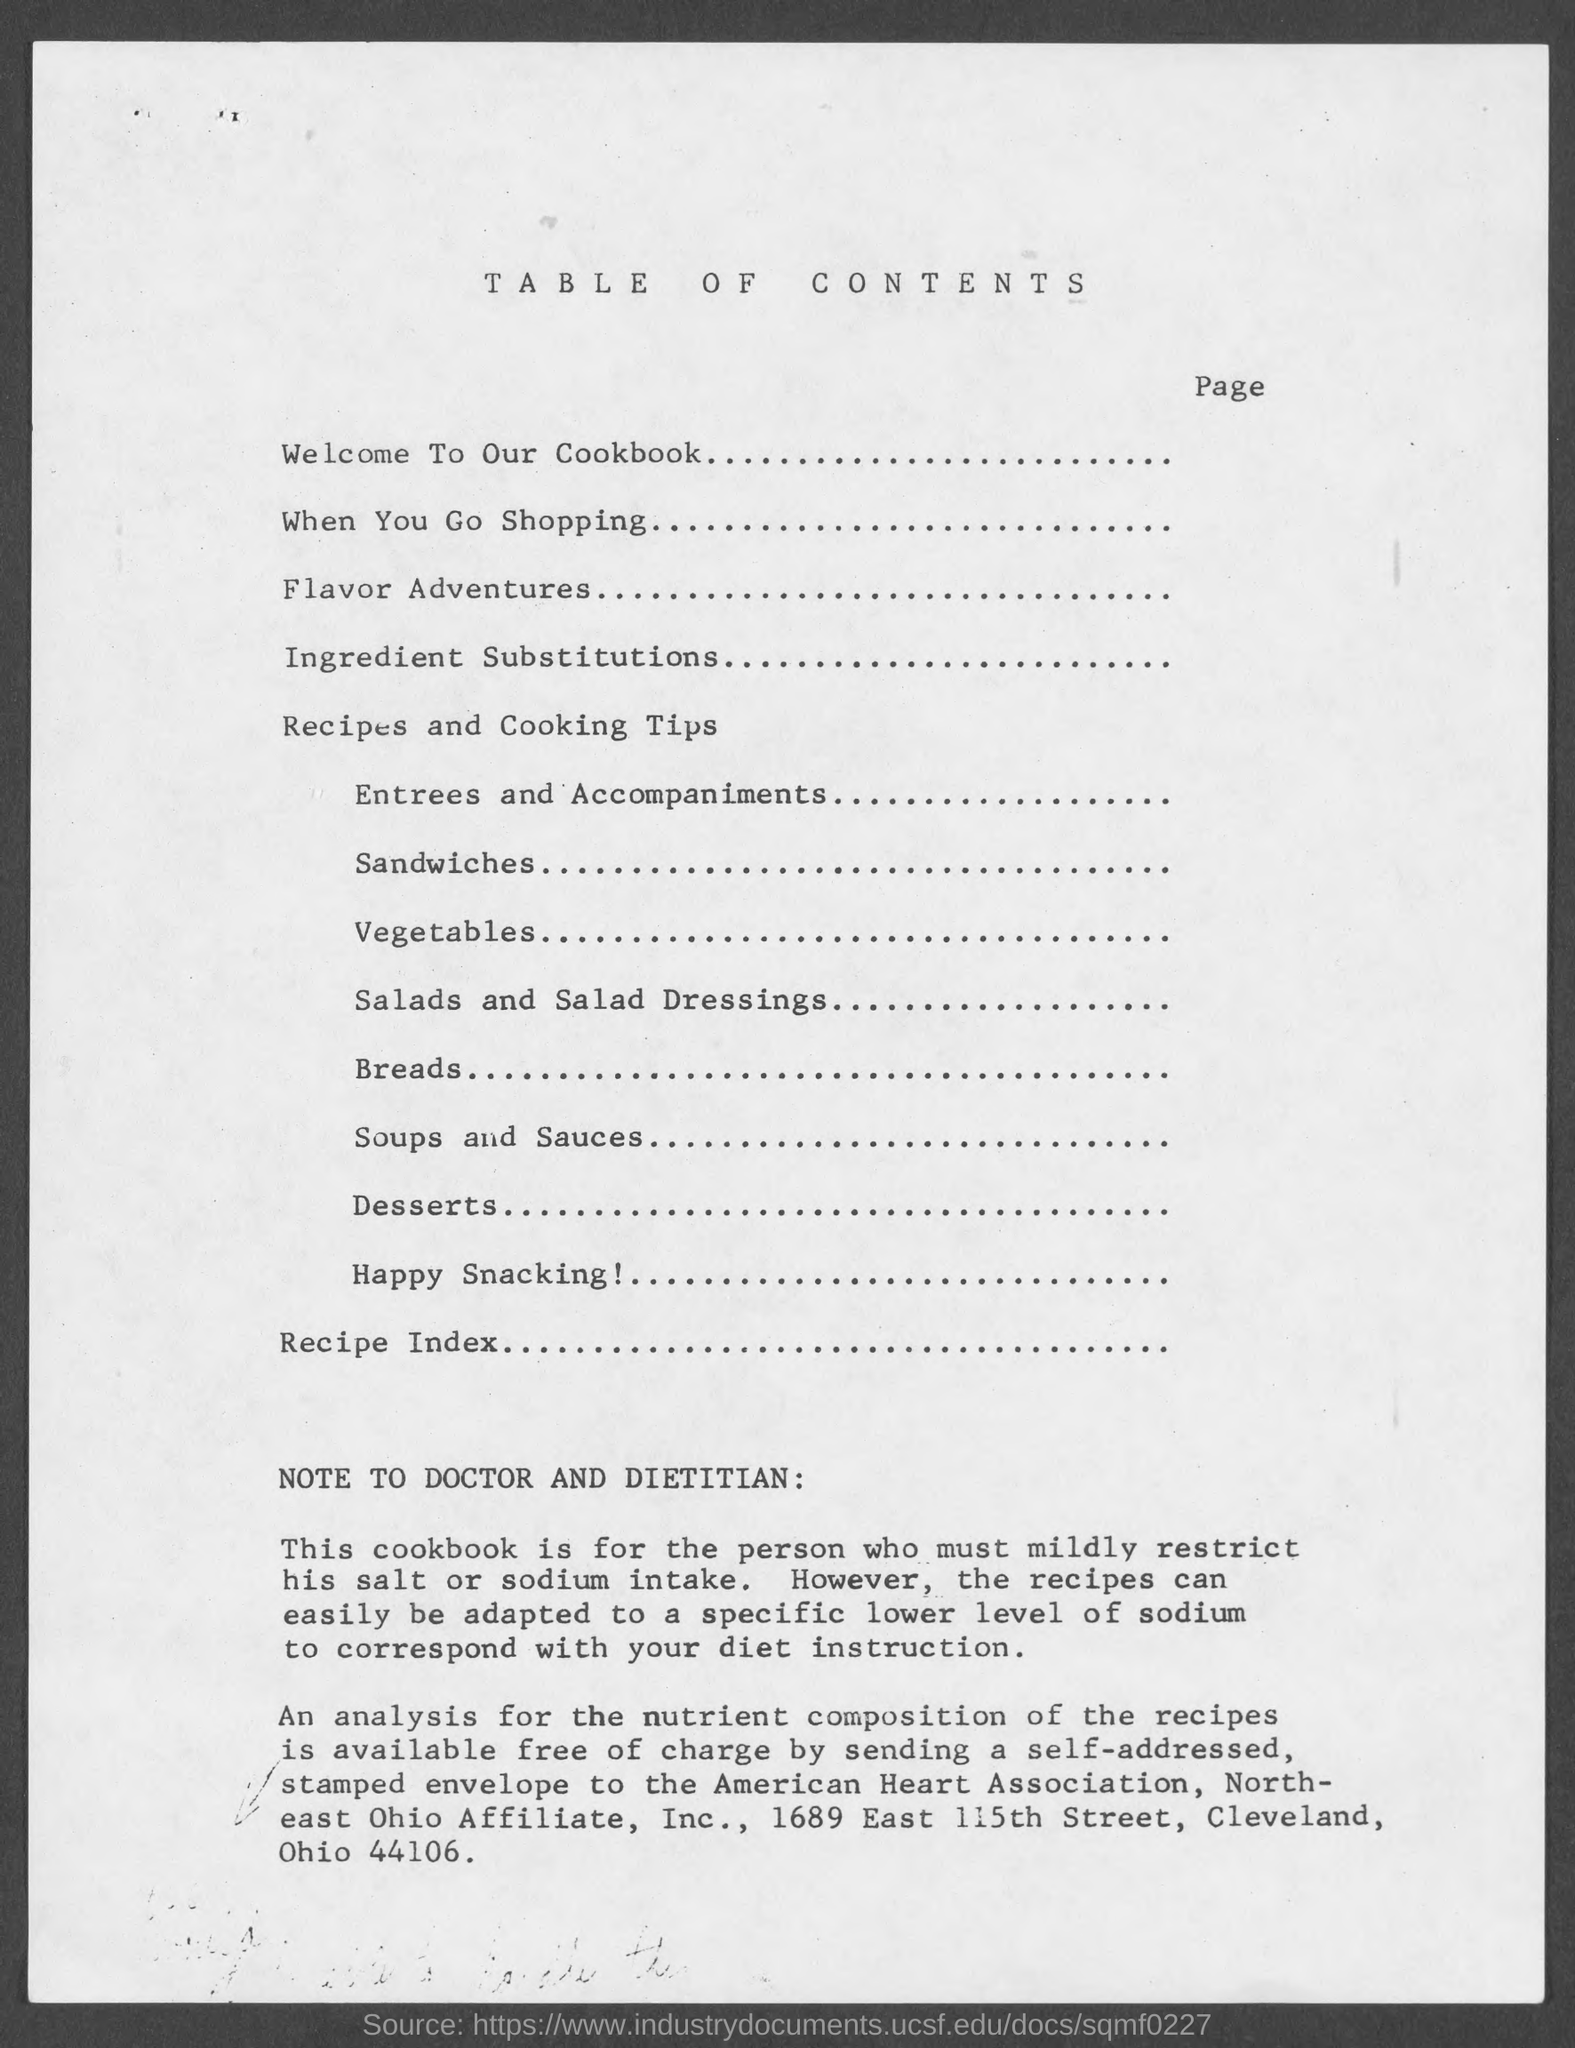What is the title of the document?
Provide a short and direct response. Table of Contents. What is the first topic?
Your answer should be compact. Welcome to our cookbook. What is the second topic?
Your answer should be very brief. When you go Shopping. What is the third topic?
Ensure brevity in your answer.  Flavor Adventures. 